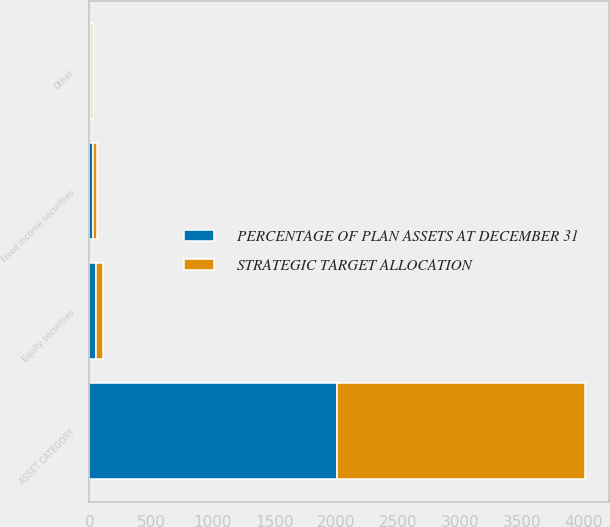<chart> <loc_0><loc_0><loc_500><loc_500><stacked_bar_chart><ecel><fcel>ASSET CATEGORY<fcel>Equity securities<fcel>Fixed income securities<fcel>Other<nl><fcel>PERCENTAGE OF PLAN ASSETS AT DECEMBER 31<fcel>2004<fcel>55<fcel>30<fcel>15<nl><fcel>STRATEGIC TARGET ALLOCATION<fcel>2003<fcel>58<fcel>30<fcel>12<nl></chart> 